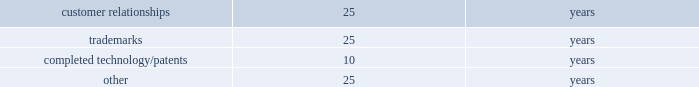Table of contents recoverability of goodwill is measured at the reporting unit level and begins with a qualitative assessment to determine if it is more likely than not that the fair value of each reporting unit is less than its carrying amount as a basis for determining whether it is necessary to perform the two-step goodwill impairment test prescribed by gaap .
For those reporting units where it is required , the first step compares the carrying amount of the reporting unit to its estimated fair value .
If the estimated fair value of a reporting unit exceeds its carrying amount , goodwill of the reporting unit is not impaired and the second step of the impairment test is not necessary .
To the extent that the carrying value of the reporting unit exceeds its estimated fair value , a second step is performed , wherein the reporting unit's carrying value of goodwill is compared to the implied fair value of goodwill .
To the extent that the carrying value exceeds the implied fair value , impairment exists and must be recognized .
The calculation of estimated fair value is based on two valuation techniques , a discounted cash flow model ( income approach ) and a market adjusted multiple of earnings and revenues ( market approach ) , with each method being weighted in the calculation .
The implied fair value of goodwill is determined in the same manner as the amount of goodwill recognized in a business combination .
The estimated fair value of the reporting unit is allocated to all of the assets and liabilities of the reporting unit ( including any unrecognized intangible assets ) as if the reporting unit had been acquired in a business combination and the fair value of the reporting unit , as determined in the first step of the goodwill impairment test , was the price paid to acquire that reporting unit .
Recoverability of other intangible assets with indefinite useful lives ( i.e .
Trademarks ) is determined on a relief from royalty methodology ( income approach ) , which is based on the implied royalty paid , at an appropriate discount rate , to license the use of an asset rather than owning the asset .
The present value of the after-tax cost savings ( i.e .
Royalty relief ) indicates the estimated fair value of the asset .
Any excess of the carrying value over the estimated fair value is recognized as an impairment loss equal to that excess .
Intangible assets such as patents , customer-related intangible assets and other intangible assets with finite useful lives are amortized on a straight-line basis over their estimated economic lives .
The weighted-average useful lives approximate the following: .
Recoverability of intangible assets with finite useful lives is assessed in the same manner as property , plant and equipment as described above .
Income taxes : for purposes of the company 2019s consolidated financial statements for periods prior to the spin-off , income tax expense has been recorded as if the company filed tax returns on a stand-alone basis separate from ingersoll rand .
This separate return methodology applies the accounting guidance for income taxes to the stand-alone financial statements as if the company was a stand-alone enterprise for the periods prior to the spin-off .
Therefore , cash tax payments and items of current and deferred taxes may not be reflective of the company 2019s actual tax balances prior to or subsequent to the spin-off .
Cash paid for income taxes for the year ended december 31 , 2015 was $ 80.6 million .
The income tax accounts reflected in the consolidated balance sheets as of december 31 , 2015 and 2014 include income taxes payable and deferred taxes allocated to the company at the time of the spin-off .
The calculation of the company 2019s income taxes involves considerable judgment and the use of both estimates and allocations .
Deferred tax assets and liabilities are determined based on temporary differences between financial reporting and tax bases of assets and liabilities , applying enacted tax rates expected to be in effect for the year in which the differences are expected to reverse .
The company recognizes future tax benefits , such as net operating losses and tax credits , to the extent that realizing these benefits is considered in its judgment to be more likely than not .
The company regularly reviews the recoverability of its deferred tax assets considering its historic profitability , projected future taxable income , timing of the reversals of existing temporary differences and the feasibility of its tax planning strategies .
Where appropriate , the company records a valuation allowance with respect to a future tax benefit .
Product warranties : standard product warranty accruals are recorded at the time of sale and are estimated based upon product warranty terms and historical experience .
The company assesses the adequacy of its liabilities and will make adjustments as necessary based on known or anticipated warranty claims , or as new information becomes available. .
What is the average weighted-average useful life for all those intangible assets , in number of years? 
Rationale: it is the sum of all weighted-average useful lives divided by four ( number of intangible assets ) .
Computations: (((25 + 25) + (25 + 10)) / 4)
Answer: 21.25. 